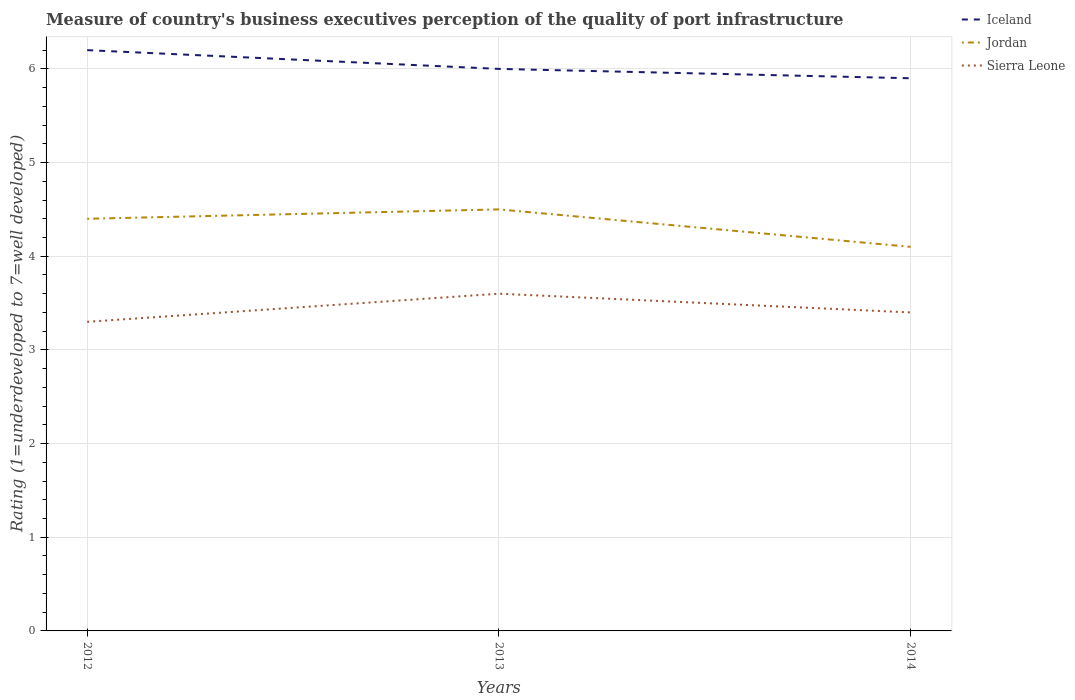What is the total ratings of the quality of port infrastructure in Sierra Leone in the graph?
Provide a short and direct response. -0.3. What is the difference between the highest and the second highest ratings of the quality of port infrastructure in Jordan?
Your answer should be very brief. 0.4. What is the difference between the highest and the lowest ratings of the quality of port infrastructure in Jordan?
Your response must be concise. 2. Is the ratings of the quality of port infrastructure in Jordan strictly greater than the ratings of the quality of port infrastructure in Sierra Leone over the years?
Offer a terse response. No. How many lines are there?
Provide a succinct answer. 3. How many years are there in the graph?
Offer a very short reply. 3. What is the difference between two consecutive major ticks on the Y-axis?
Offer a very short reply. 1. Are the values on the major ticks of Y-axis written in scientific E-notation?
Provide a short and direct response. No. Does the graph contain grids?
Provide a short and direct response. Yes. Where does the legend appear in the graph?
Keep it short and to the point. Top right. How are the legend labels stacked?
Offer a terse response. Vertical. What is the title of the graph?
Ensure brevity in your answer.  Measure of country's business executives perception of the quality of port infrastructure. What is the label or title of the X-axis?
Provide a succinct answer. Years. What is the label or title of the Y-axis?
Ensure brevity in your answer.  Rating (1=underdeveloped to 7=well developed). What is the Rating (1=underdeveloped to 7=well developed) in Iceland in 2012?
Provide a short and direct response. 6.2. What is the Rating (1=underdeveloped to 7=well developed) in Jordan in 2012?
Provide a succinct answer. 4.4. What is the Rating (1=underdeveloped to 7=well developed) of Iceland in 2013?
Give a very brief answer. 6. What is the Rating (1=underdeveloped to 7=well developed) of Jordan in 2014?
Offer a very short reply. 4.1. What is the Rating (1=underdeveloped to 7=well developed) of Sierra Leone in 2014?
Keep it short and to the point. 3.4. Across all years, what is the maximum Rating (1=underdeveloped to 7=well developed) in Jordan?
Your answer should be compact. 4.5. Across all years, what is the maximum Rating (1=underdeveloped to 7=well developed) in Sierra Leone?
Keep it short and to the point. 3.6. Across all years, what is the minimum Rating (1=underdeveloped to 7=well developed) in Jordan?
Provide a short and direct response. 4.1. Across all years, what is the minimum Rating (1=underdeveloped to 7=well developed) in Sierra Leone?
Provide a short and direct response. 3.3. What is the difference between the Rating (1=underdeveloped to 7=well developed) of Iceland in 2012 and that in 2013?
Offer a terse response. 0.2. What is the difference between the Rating (1=underdeveloped to 7=well developed) of Jordan in 2012 and that in 2013?
Offer a very short reply. -0.1. What is the difference between the Rating (1=underdeveloped to 7=well developed) of Sierra Leone in 2012 and that in 2013?
Make the answer very short. -0.3. What is the difference between the Rating (1=underdeveloped to 7=well developed) of Jordan in 2012 and that in 2014?
Provide a succinct answer. 0.3. What is the difference between the Rating (1=underdeveloped to 7=well developed) of Iceland in 2012 and the Rating (1=underdeveloped to 7=well developed) of Jordan in 2013?
Ensure brevity in your answer.  1.7. What is the difference between the Rating (1=underdeveloped to 7=well developed) in Iceland in 2013 and the Rating (1=underdeveloped to 7=well developed) in Sierra Leone in 2014?
Your answer should be very brief. 2.6. What is the average Rating (1=underdeveloped to 7=well developed) in Iceland per year?
Provide a short and direct response. 6.03. What is the average Rating (1=underdeveloped to 7=well developed) in Jordan per year?
Offer a very short reply. 4.33. What is the average Rating (1=underdeveloped to 7=well developed) in Sierra Leone per year?
Offer a very short reply. 3.43. In the year 2012, what is the difference between the Rating (1=underdeveloped to 7=well developed) in Jordan and Rating (1=underdeveloped to 7=well developed) in Sierra Leone?
Provide a short and direct response. 1.1. In the year 2013, what is the difference between the Rating (1=underdeveloped to 7=well developed) of Iceland and Rating (1=underdeveloped to 7=well developed) of Jordan?
Offer a very short reply. 1.5. In the year 2013, what is the difference between the Rating (1=underdeveloped to 7=well developed) in Iceland and Rating (1=underdeveloped to 7=well developed) in Sierra Leone?
Give a very brief answer. 2.4. In the year 2013, what is the difference between the Rating (1=underdeveloped to 7=well developed) in Jordan and Rating (1=underdeveloped to 7=well developed) in Sierra Leone?
Give a very brief answer. 0.9. In the year 2014, what is the difference between the Rating (1=underdeveloped to 7=well developed) of Iceland and Rating (1=underdeveloped to 7=well developed) of Jordan?
Keep it short and to the point. 1.8. In the year 2014, what is the difference between the Rating (1=underdeveloped to 7=well developed) in Iceland and Rating (1=underdeveloped to 7=well developed) in Sierra Leone?
Your answer should be compact. 2.5. In the year 2014, what is the difference between the Rating (1=underdeveloped to 7=well developed) in Jordan and Rating (1=underdeveloped to 7=well developed) in Sierra Leone?
Give a very brief answer. 0.7. What is the ratio of the Rating (1=underdeveloped to 7=well developed) in Iceland in 2012 to that in 2013?
Your answer should be very brief. 1.03. What is the ratio of the Rating (1=underdeveloped to 7=well developed) of Jordan in 2012 to that in 2013?
Your answer should be compact. 0.98. What is the ratio of the Rating (1=underdeveloped to 7=well developed) of Sierra Leone in 2012 to that in 2013?
Provide a succinct answer. 0.92. What is the ratio of the Rating (1=underdeveloped to 7=well developed) of Iceland in 2012 to that in 2014?
Offer a very short reply. 1.05. What is the ratio of the Rating (1=underdeveloped to 7=well developed) in Jordan in 2012 to that in 2014?
Offer a terse response. 1.07. What is the ratio of the Rating (1=underdeveloped to 7=well developed) of Sierra Leone in 2012 to that in 2014?
Give a very brief answer. 0.97. What is the ratio of the Rating (1=underdeveloped to 7=well developed) in Iceland in 2013 to that in 2014?
Make the answer very short. 1.02. What is the ratio of the Rating (1=underdeveloped to 7=well developed) of Jordan in 2013 to that in 2014?
Your answer should be compact. 1.1. What is the ratio of the Rating (1=underdeveloped to 7=well developed) of Sierra Leone in 2013 to that in 2014?
Provide a succinct answer. 1.06. What is the difference between the highest and the second highest Rating (1=underdeveloped to 7=well developed) of Sierra Leone?
Your response must be concise. 0.2. What is the difference between the highest and the lowest Rating (1=underdeveloped to 7=well developed) in Iceland?
Keep it short and to the point. 0.3. What is the difference between the highest and the lowest Rating (1=underdeveloped to 7=well developed) in Jordan?
Your answer should be very brief. 0.4. 